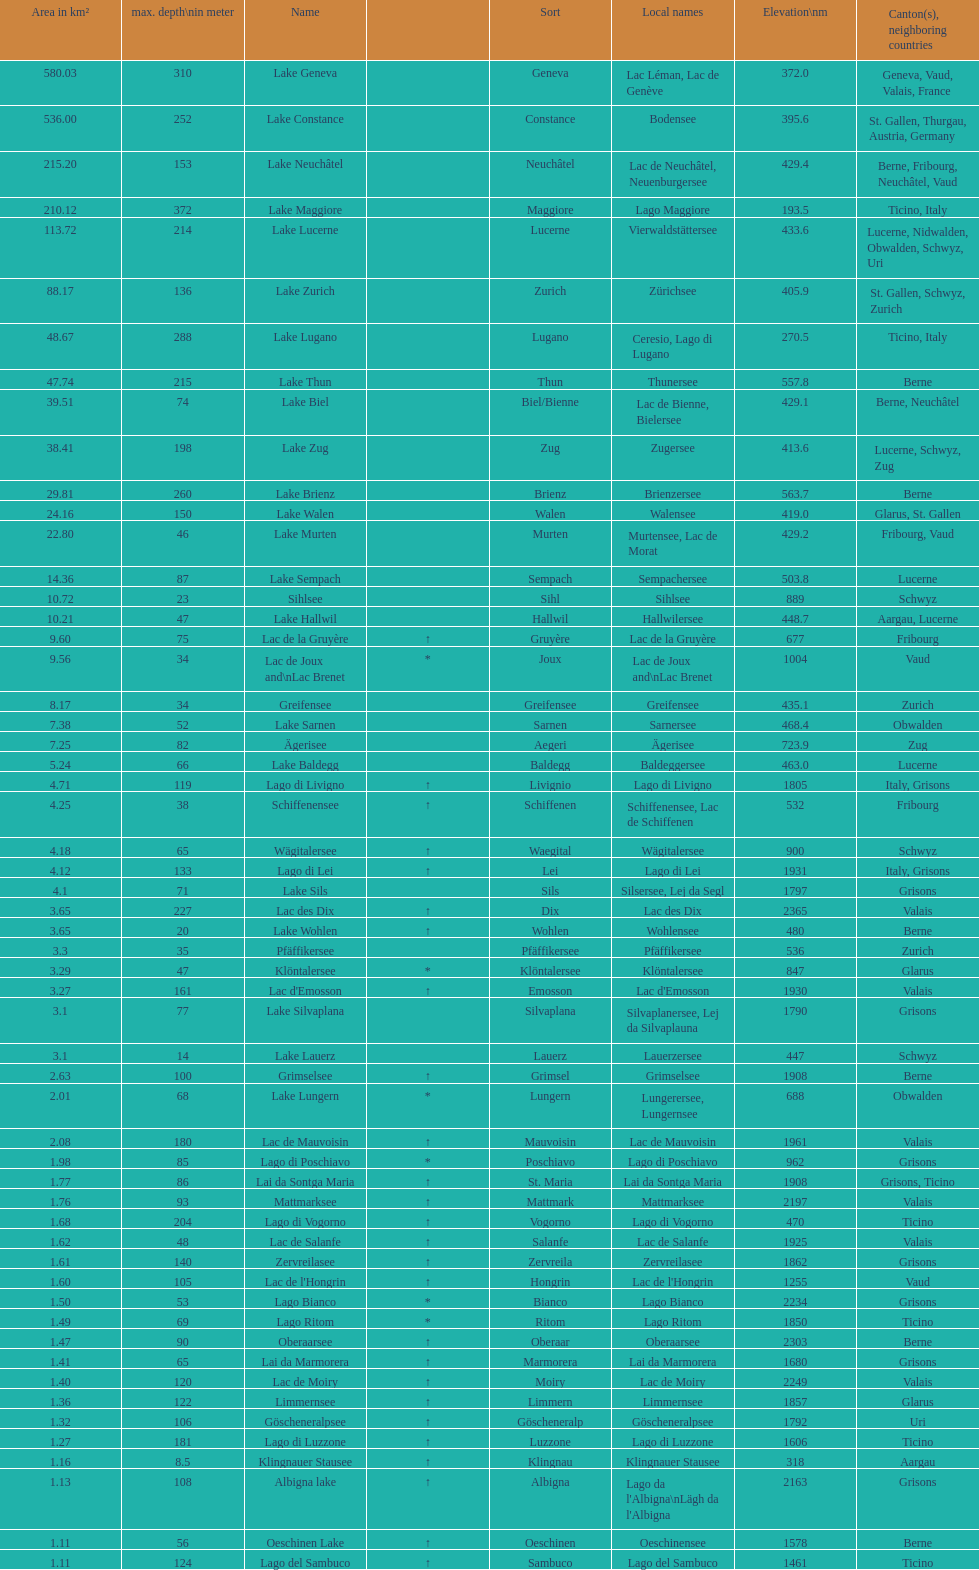Which lake has the largest elevation? Lac des Dix. 